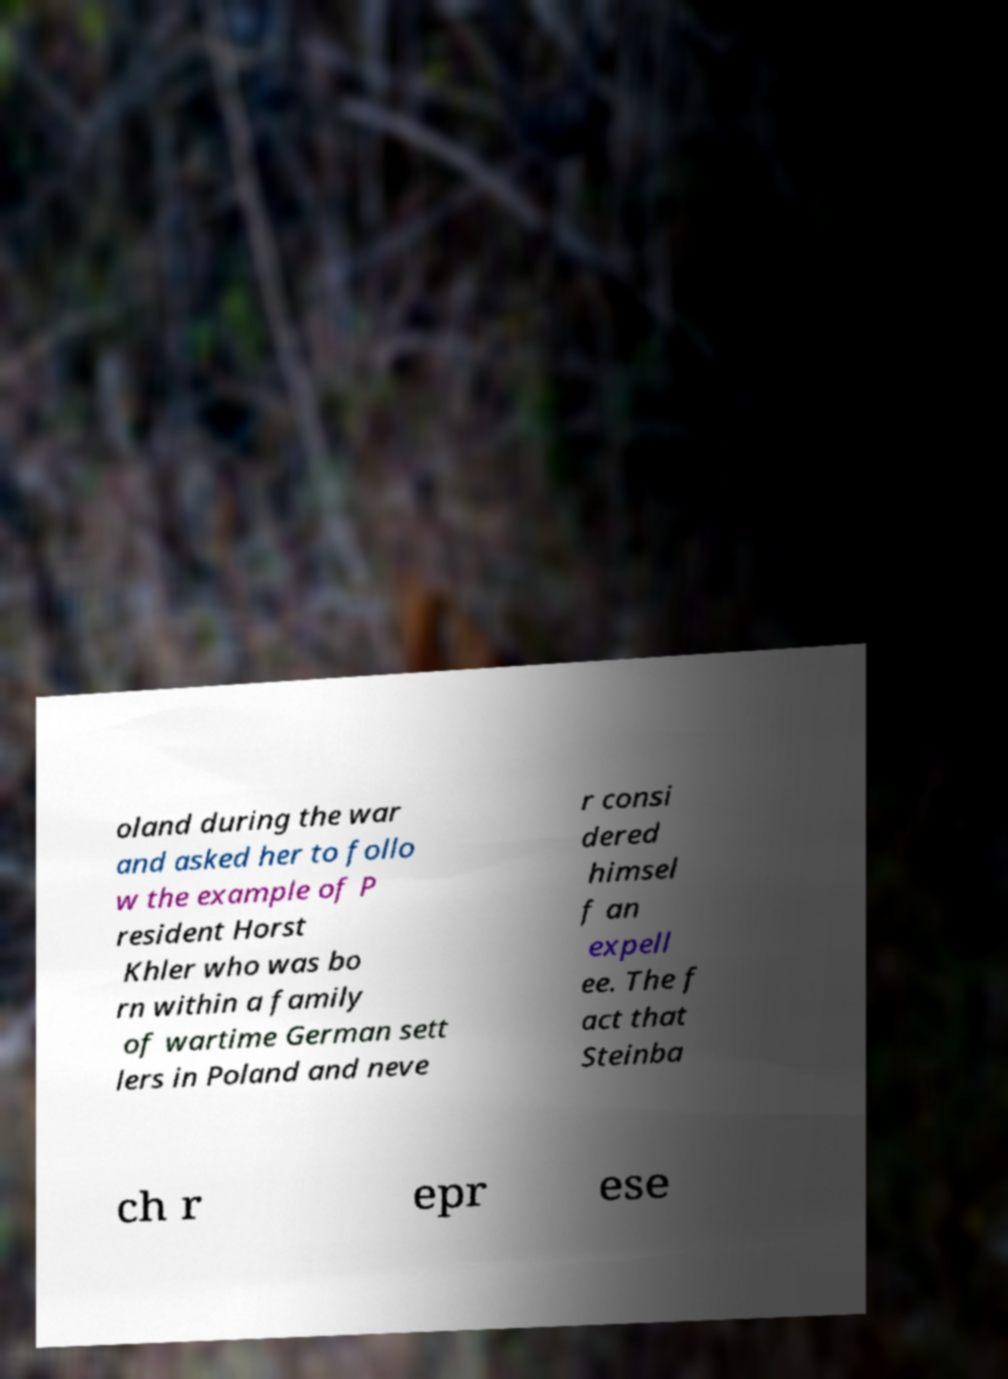Please identify and transcribe the text found in this image. oland during the war and asked her to follo w the example of P resident Horst Khler who was bo rn within a family of wartime German sett lers in Poland and neve r consi dered himsel f an expell ee. The f act that Steinba ch r epr ese 